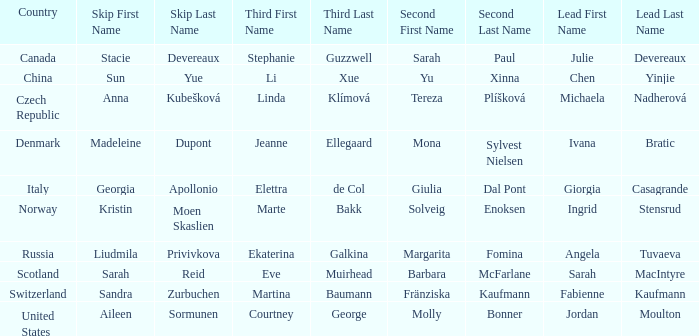What skip has martina baumann as the third? Sandra Zurbuchen. 